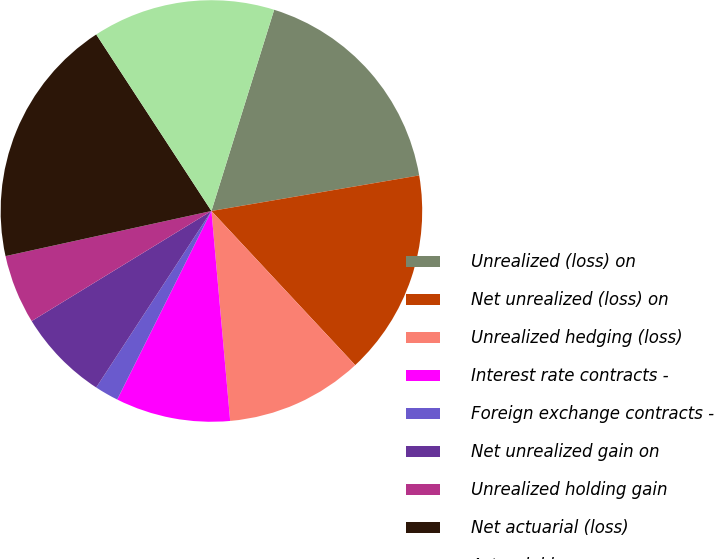Convert chart to OTSL. <chart><loc_0><loc_0><loc_500><loc_500><pie_chart><fcel>Unrealized (loss) on<fcel>Net unrealized (loss) on<fcel>Unrealized hedging (loss)<fcel>Interest rate contracts -<fcel>Foreign exchange contracts -<fcel>Net unrealized gain on<fcel>Unrealized holding gain<fcel>Net actuarial (loss)<fcel>Actuarial loss<nl><fcel>17.49%<fcel>15.75%<fcel>10.53%<fcel>8.79%<fcel>1.83%<fcel>7.05%<fcel>5.31%<fcel>19.23%<fcel>14.01%<nl></chart> 